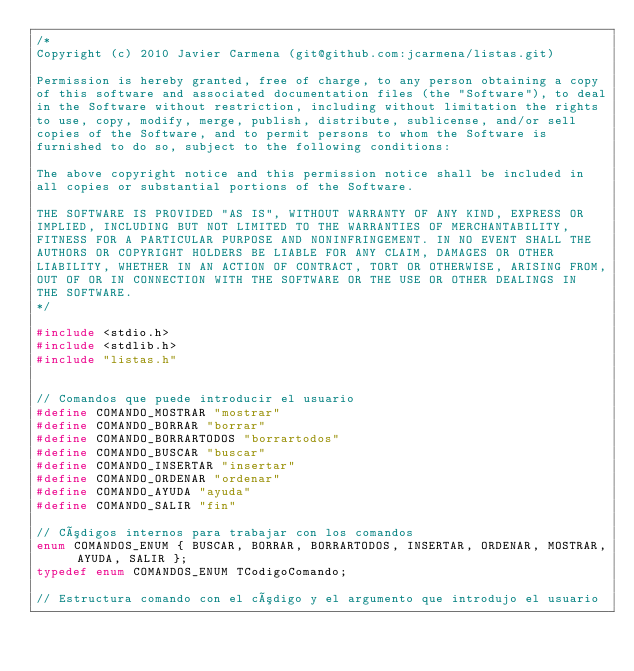Convert code to text. <code><loc_0><loc_0><loc_500><loc_500><_C_>/*
Copyright (c) 2010 Javier Carmena (git@github.com:jcarmena/listas.git)

Permission is hereby granted, free of charge, to any person obtaining a copy
of this software and associated documentation files (the "Software"), to deal
in the Software without restriction, including without limitation the rights
to use, copy, modify, merge, publish, distribute, sublicense, and/or sell
copies of the Software, and to permit persons to whom the Software is
furnished to do so, subject to the following conditions:

The above copyright notice and this permission notice shall be included in
all copies or substantial portions of the Software.

THE SOFTWARE IS PROVIDED "AS IS", WITHOUT WARRANTY OF ANY KIND, EXPRESS OR
IMPLIED, INCLUDING BUT NOT LIMITED TO THE WARRANTIES OF MERCHANTABILITY,
FITNESS FOR A PARTICULAR PURPOSE AND NONINFRINGEMENT. IN NO EVENT SHALL THE
AUTHORS OR COPYRIGHT HOLDERS BE LIABLE FOR ANY CLAIM, DAMAGES OR OTHER
LIABILITY, WHETHER IN AN ACTION OF CONTRACT, TORT OR OTHERWISE, ARISING FROM,
OUT OF OR IN CONNECTION WITH THE SOFTWARE OR THE USE OR OTHER DEALINGS IN
THE SOFTWARE.
*/

#include <stdio.h>
#include <stdlib.h>
#include "listas.h"


// Comandos que puede introducir el usuario
#define COMANDO_MOSTRAR "mostrar"
#define COMANDO_BORRAR "borrar"
#define COMANDO_BORRARTODOS "borrartodos"
#define COMANDO_BUSCAR "buscar"
#define COMANDO_INSERTAR "insertar"
#define COMANDO_ORDENAR "ordenar"
#define COMANDO_AYUDA "ayuda"
#define COMANDO_SALIR "fin"

// Códigos internos para trabajar con los comandos
enum COMANDOS_ENUM { BUSCAR, BORRAR, BORRARTODOS, INSERTAR, ORDENAR, MOSTRAR, AYUDA, SALIR };
typedef enum COMANDOS_ENUM TCodigoComando;

// Estructura comando con el código y el argumento que introdujo el usuario</code> 